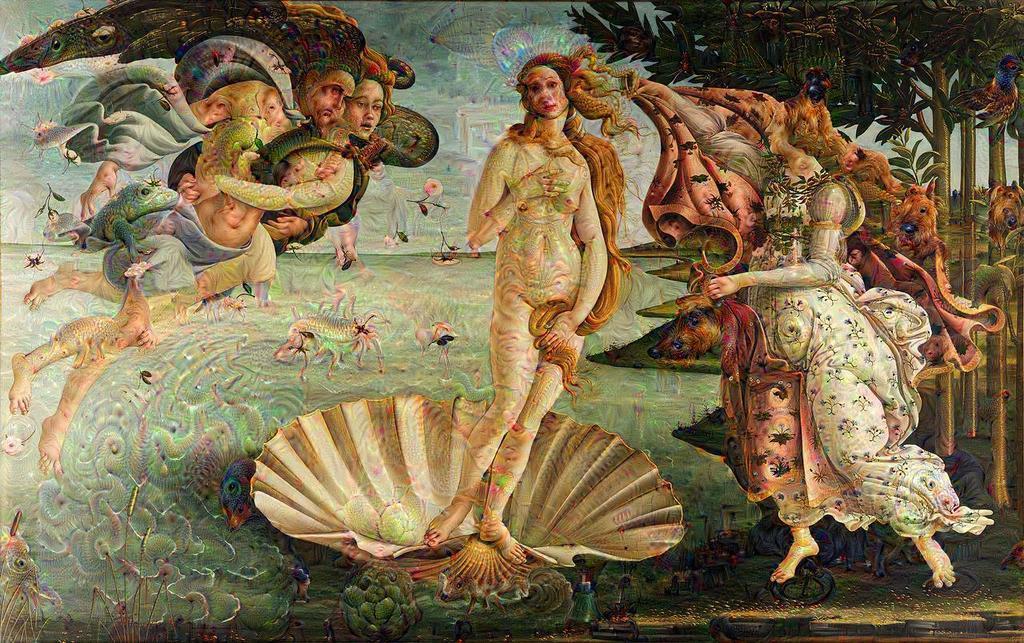Can you describe this image briefly? In this picture I can see painting of people, trees and other things. 